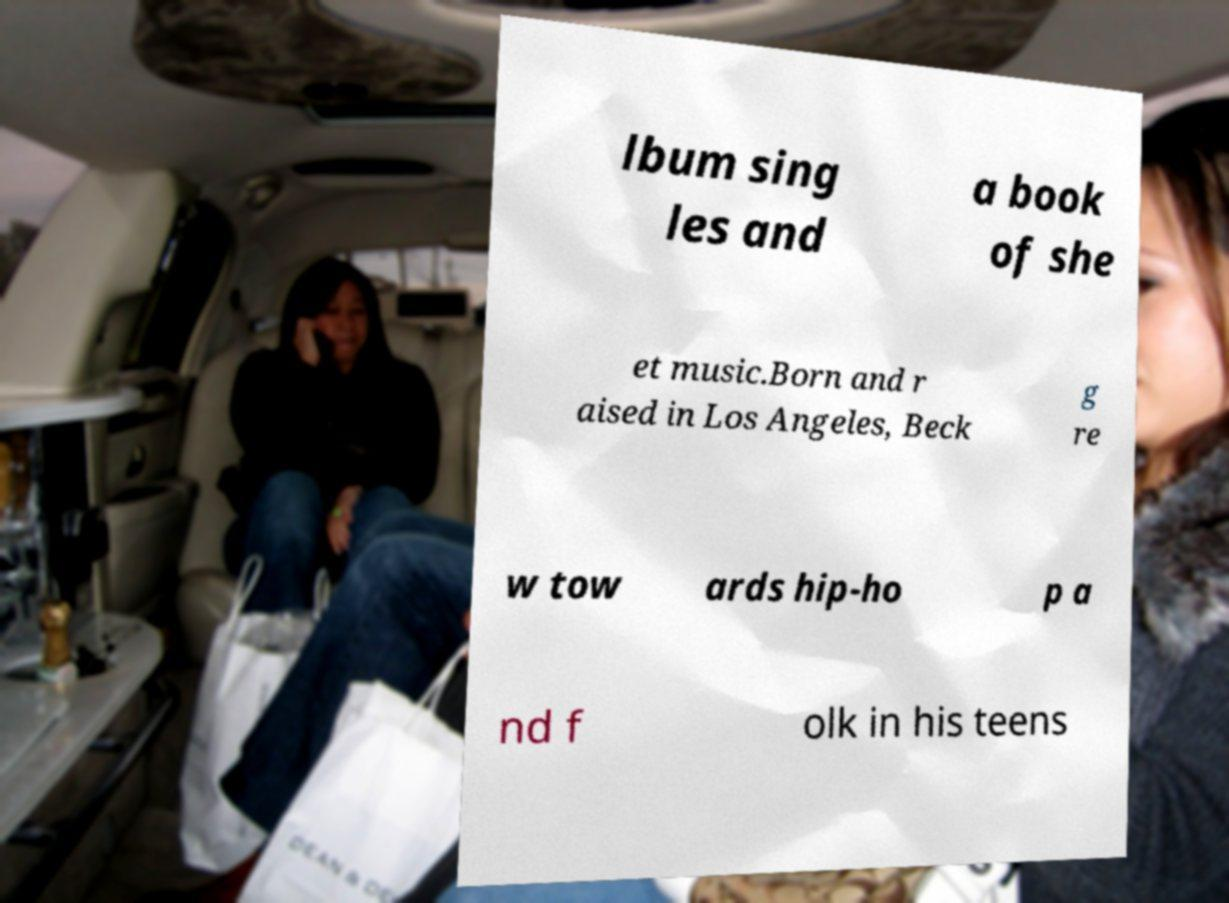There's text embedded in this image that I need extracted. Can you transcribe it verbatim? lbum sing les and a book of she et music.Born and r aised in Los Angeles, Beck g re w tow ards hip-ho p a nd f olk in his teens 